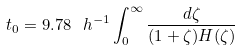Convert formula to latex. <formula><loc_0><loc_0><loc_500><loc_500>t _ { 0 } = 9 . 7 8 \ h ^ { - 1 } \int _ { 0 } ^ { \infty } { \frac { d \zeta } { ( 1 + \zeta ) H ( \zeta ) } }</formula> 